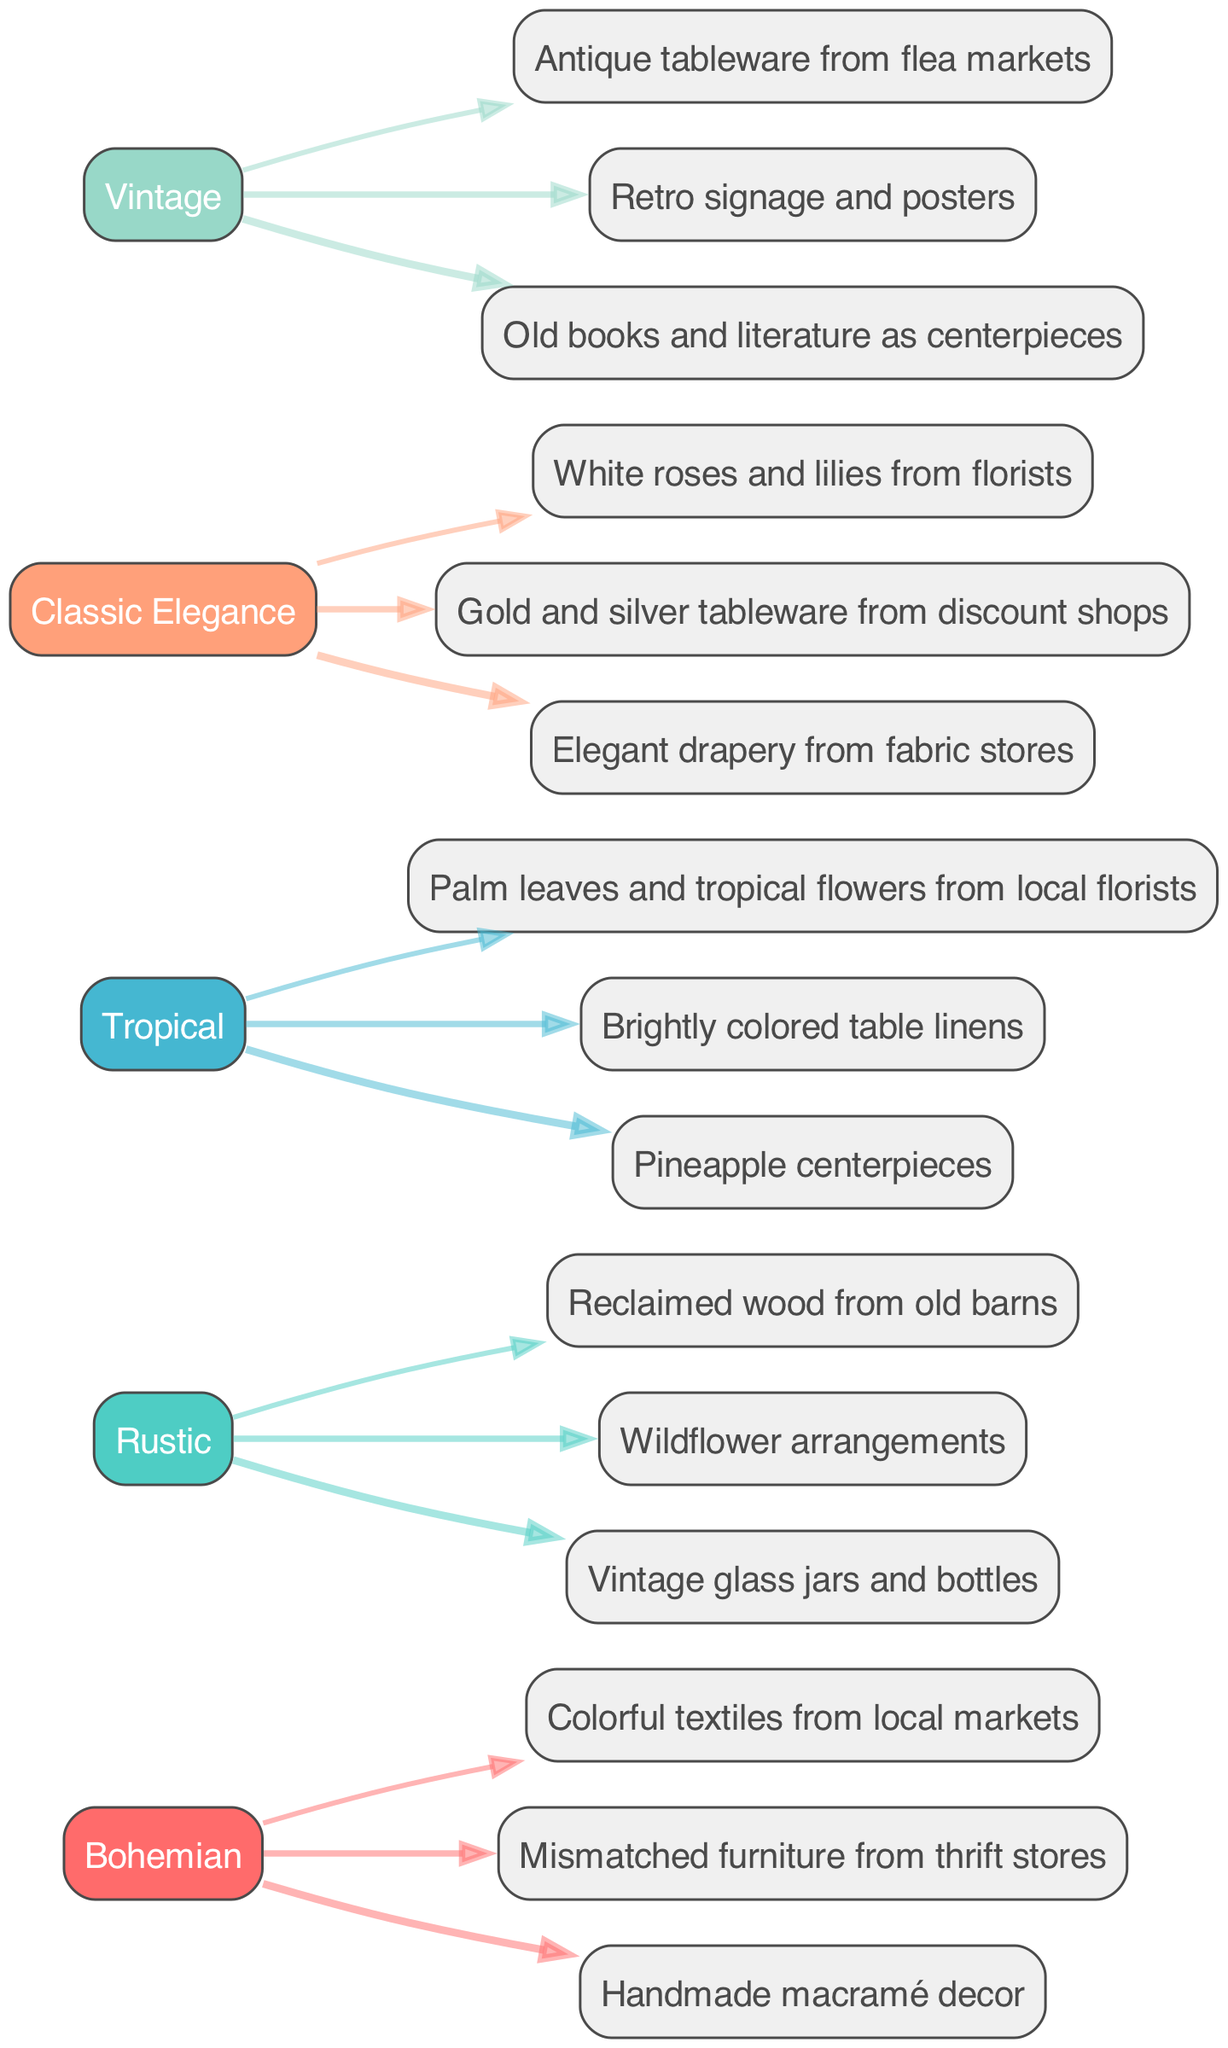What theme has the most inspirations? By examining the diagram, I can see that each theme is connected to multiple inspiration nodes. The total number of inspirations must be counted for each theme, and in this case, each theme has three inspirations. Therefore, all themes are equal in the number of inspirations.
Answer: Three Which theme features mismatched furniture as an inspiration? Looking at the nodes connected to the "Bohemian" theme, one of the inspirations listed is "Mismatched furniture from thrift stores." Therefore, the theme that features this inspiration is "Bohemian."
Answer: Bohemian How many total inspirations are represented in the diagram? Each theme has three inspirations, and there are five themes in total. To find the total number of inspirations, I multiply the number of themes by the number of inspirations per theme: 5 themes x 3 inspirations = 15 inspirations.
Answer: Fifteen Which theme contains pineapple centerpieces among its inspirations? Searching the connections from the "Tropical" theme, I find that one of the inspirations listed is "Pineapple centerpieces." This indicates that the "Tropical" theme contains this inspiration.
Answer: Tropical What is the relationship between vintage glass jars and the Rustic theme? The inspiration "Vintage glass jars and bottles" is directly connected to the "Rustic" theme node, indicating that this inspiration belongs to the Rustic theme.
Answer: Rustic 